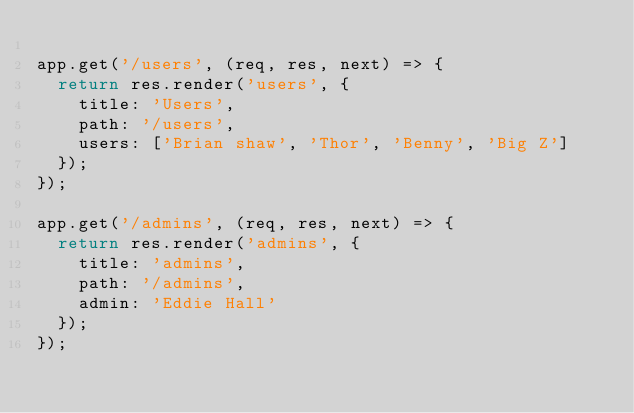<code> <loc_0><loc_0><loc_500><loc_500><_JavaScript_>
app.get('/users', (req, res, next) => {
  return res.render('users', {
    title: 'Users',
    path: '/users',
    users: ['Brian shaw', 'Thor', 'Benny', 'Big Z']
  });
});

app.get('/admins', (req, res, next) => {
  return res.render('admins', {
    title: 'admins',
    path: '/admins',
    admin: 'Eddie Hall'
  });
});</code> 